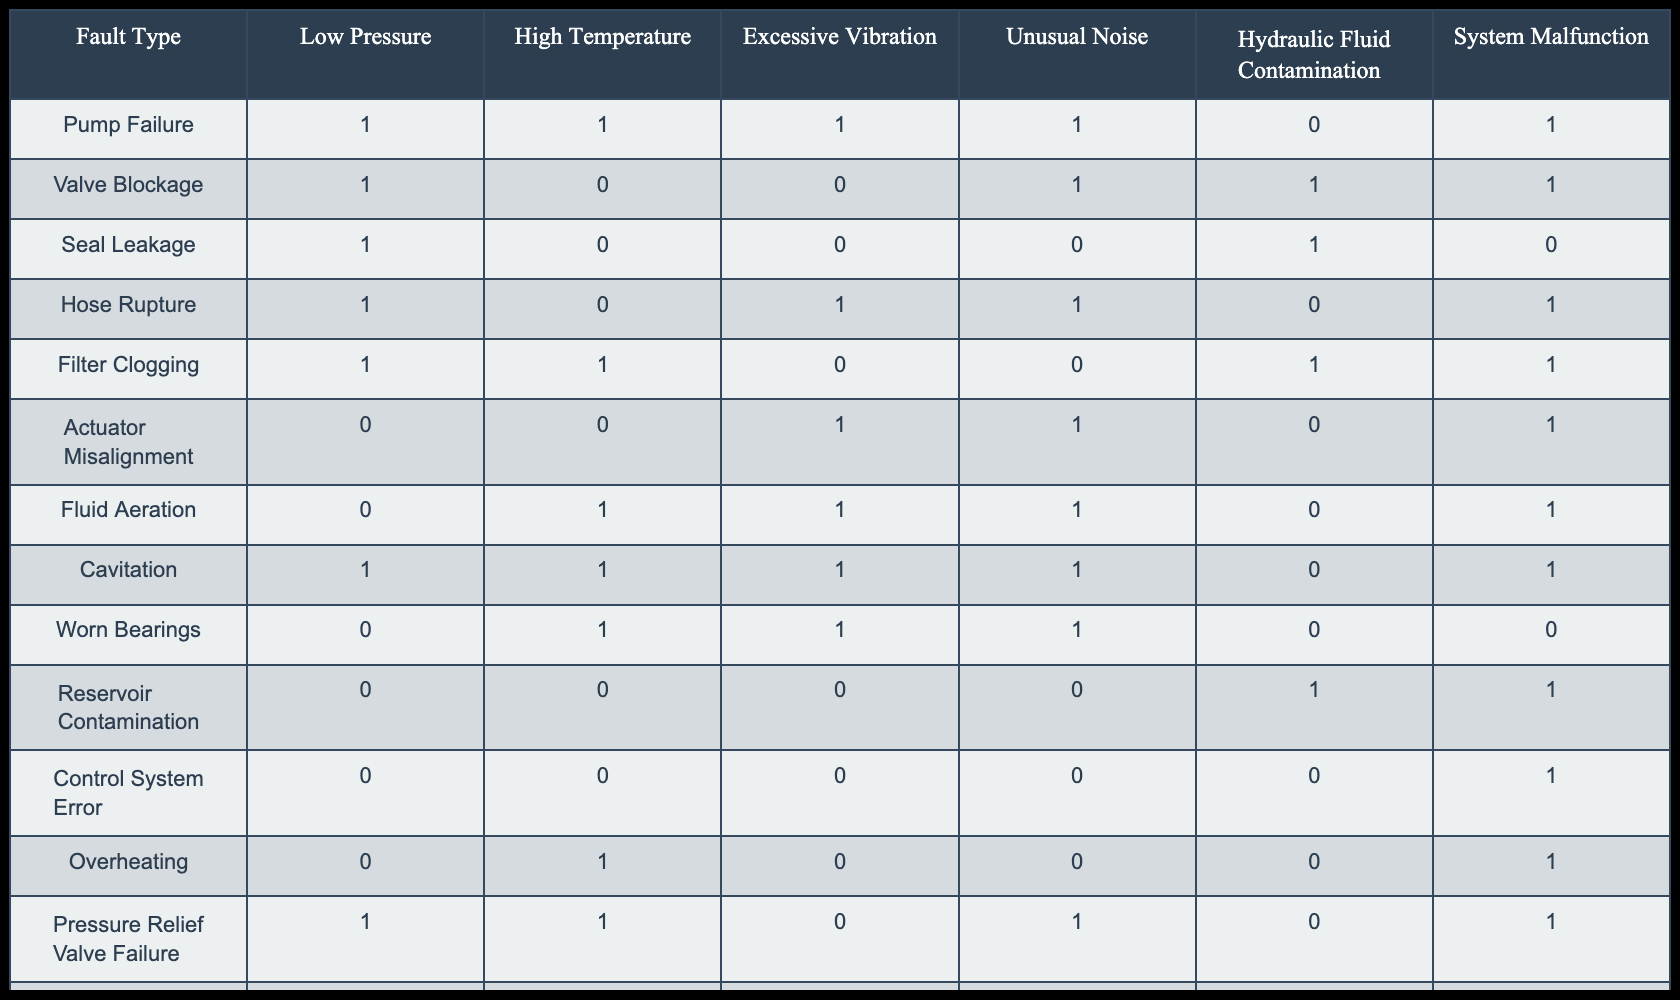What fault type is associated with high temperature and unusual noise but not with hydraulic fluid contamination? The table indicates that the "Hose Rupture" fault type has a high temperature (1) and unusual noise (1), while showing no hydraulic fluid contamination (0). This meets the criteria specified.
Answer: Hose Rupture How many fault types involve both high temperature and excessive vibration? By examining the table, the fault types "Pump Failure," "Cavitation," and "Worn Bearings" are noted to have both high temperature (1) and excessive vibration (1). There are three such fault types.
Answer: 3 Is seal leakage causing unusual noise? The table shows that with "Seal Leakage," the value for unusual noise is (0), indicating that it does not cause unusual noise. Therefore, the statement is false.
Answer: No Which fault type has the least number of categories marked as '1'? By reviewing the table, "Seal Leakage" has the least occurrences of '1' values, with only three categories marked (Low Pressure, High Temperature, and Hydraulic Fluid Contamination). This makes it the fault type with the fewest active indicators.
Answer: Seal Leakage If we consider only those faults with hydraulic fluid contamination, what is the sum of the fault types that also show high temperature? Analyzing the table, the fault types with hydraulic fluid contamination (1) that also show high temperature (1) are "Valve Blockage" and "Filter Clogging." This leads to a total of 2 fault types that fulfill these conditions.
Answer: 2 What is the percentage of faults that are caused by excessive vibration? To determine this, we count the instances of excessive vibration marked as '1,' which are "Pump Failure," "Hose Rupture," "Actuator Misalignment," "Fluid Aeration," "Cavitation," and "Worn Bearings," totaling 6 instances. Since there are 12 fault types in total, the percentage is (6/12) * 100 = 50%.
Answer: 50% Is accumulator malfunction linked with overheating? In the table, "Accumulator Malfunction" has a value of '0' for overheating, now implying there is no link. Thus, the statement is false.
Answer: No Which is the only fault type that has neither high temperature nor unusual noise? Upon review, "Reservoir Contamination" shows '0' values for both high temperature and unusual noise. This unique combination makes it the only fault type fitting the criteria.
Answer: Reservoir Contamination 